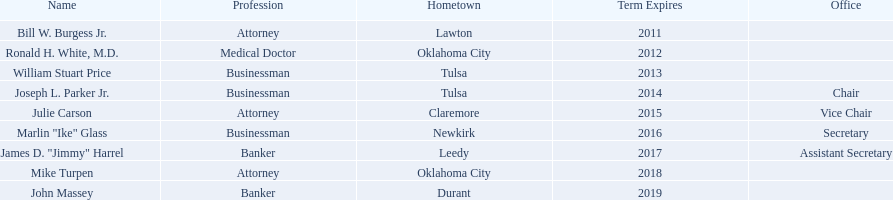What is bill w. burgess jr.'s place of origin? Lawton. Where do price and parker originate? Tulsa. Who shares the same state as white? Mike Turpen. 